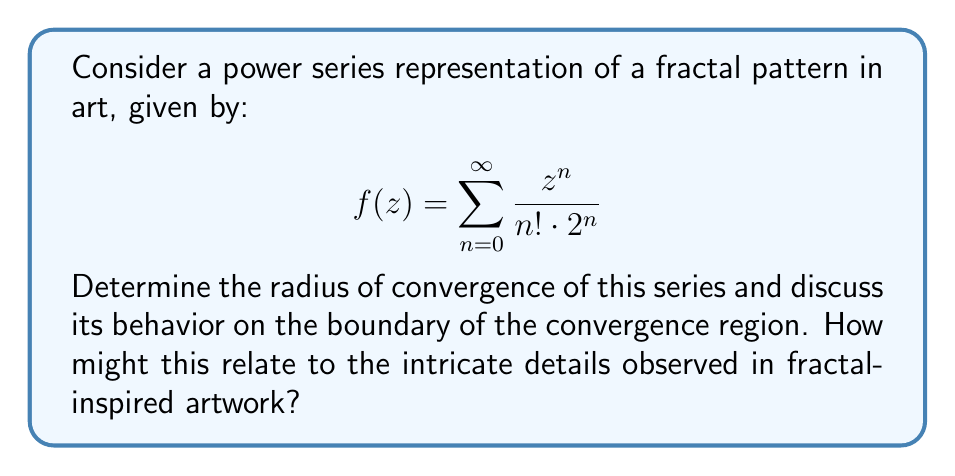Teach me how to tackle this problem. To analyze the convergence of this power series, we'll use the ratio test:

1) First, let's define the general term of the series:
   $$a_n = \frac{z^n}{n! \cdot 2^n}$$

2) Now, we'll take the limit of the ratio of consecutive terms:
   $$\lim_{n \to \infty} \left|\frac{a_{n+1}}{a_n}\right| = \lim_{n \to \infty} \left|\frac{z^{n+1}}{(n+1)! \cdot 2^{n+1}} \cdot \frac{n! \cdot 2^n}{z^n}\right|$$

3) Simplify:
   $$\lim_{n \to \infty} \left|\frac{z}{(n+1) \cdot 2}\right| = \lim_{n \to \infty} \frac{|z|}{2(n+1)} = 0$$

4) Since the limit is 0, which is less than 1, the series converges for all finite z. This means the radius of convergence is infinite.

5) To understand the behavior at infinity, we can use the comparison test with $e^{|z|}$:
   $$\left|\frac{z^n}{n! \cdot 2^n}\right| \leq \frac{|z|^n}{n!}$$
   
   The right-hand side is the general term of the Taylor series for $e^{|z|}$, which converges for all z.

6) Therefore, our series converges absolutely and uniformly on any compact subset of the complex plane.

In relation to fractal-inspired artwork, this infinite radius of convergence suggests that the mathematical representation of the fractal pattern remains well-defined and "stable" no matter how far we "zoom in" or "zoom out". This aligns with the self-similarity property of fractals, where intricate details persist at all scales. The painter could use this concept to create artwork with infinite levels of detail, theoretically allowing viewers to discover new patterns no matter how closely they examine the piece.
Answer: The radius of convergence is infinite, and the series converges absolutely and uniformly on any compact subset of the complex plane. This implies that the fractal pattern represented by this series has well-defined details at all scales, mirroring the infinite complexity often observed in fractal art. 